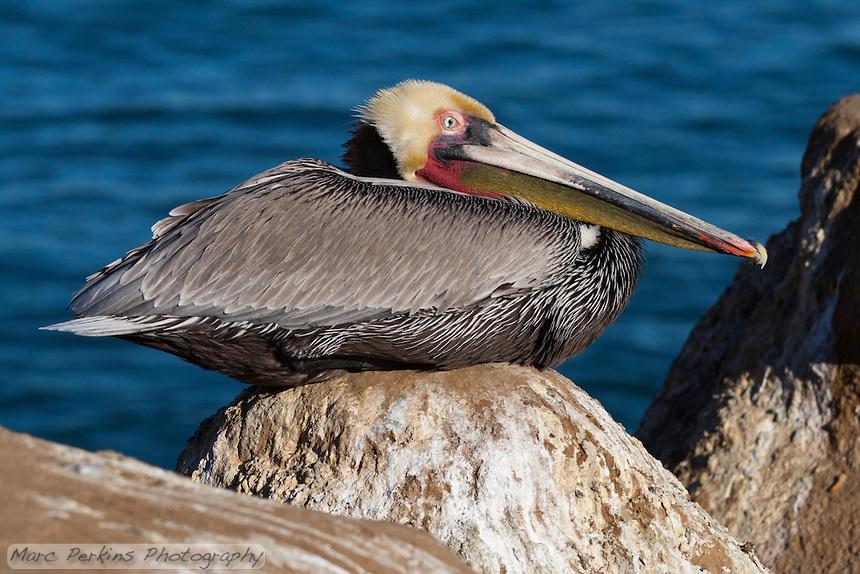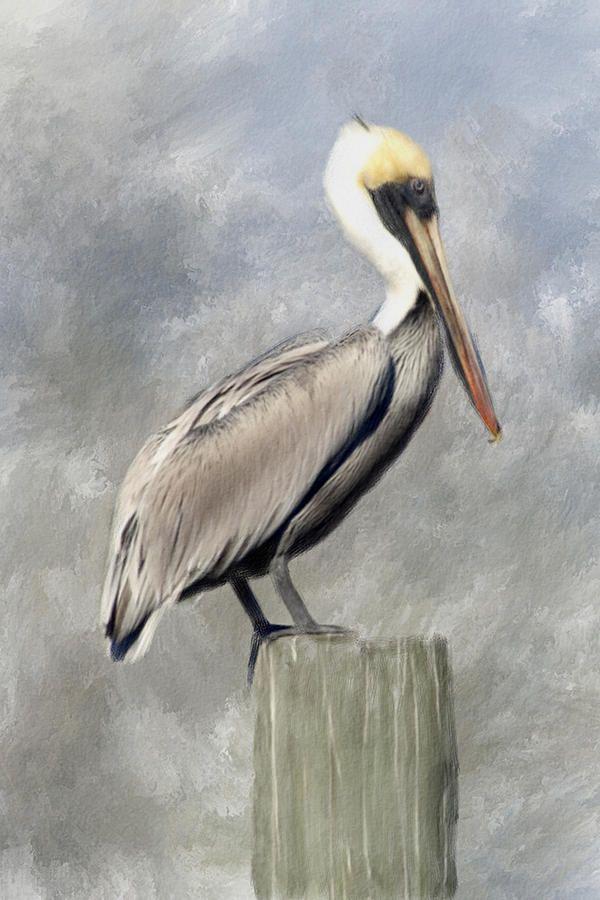The first image is the image on the left, the second image is the image on the right. Given the left and right images, does the statement "In the left image, a pelican is facing right and sitting with its neck buried in its body." hold true? Answer yes or no. Yes. The first image is the image on the left, the second image is the image on the right. For the images shown, is this caption "Each image shows one pelican perched on a post, and at least one of the birds depicted is facing rightward." true? Answer yes or no. No. 